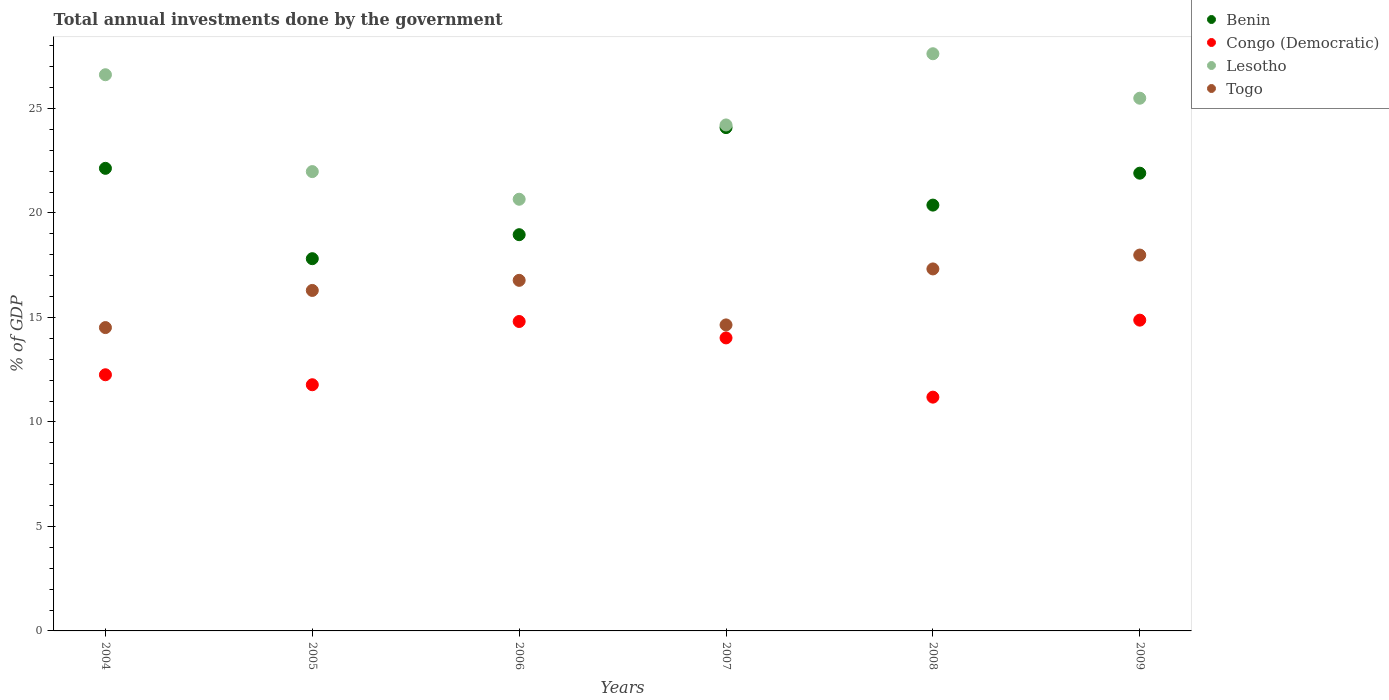How many different coloured dotlines are there?
Your answer should be compact. 4. What is the total annual investments done by the government in Togo in 2006?
Ensure brevity in your answer.  16.77. Across all years, what is the maximum total annual investments done by the government in Congo (Democratic)?
Offer a terse response. 14.87. Across all years, what is the minimum total annual investments done by the government in Togo?
Provide a succinct answer. 14.51. In which year was the total annual investments done by the government in Togo maximum?
Keep it short and to the point. 2009. In which year was the total annual investments done by the government in Togo minimum?
Your answer should be compact. 2004. What is the total total annual investments done by the government in Benin in the graph?
Your response must be concise. 125.27. What is the difference between the total annual investments done by the government in Lesotho in 2008 and that in 2009?
Offer a very short reply. 2.13. What is the difference between the total annual investments done by the government in Lesotho in 2006 and the total annual investments done by the government in Togo in 2004?
Ensure brevity in your answer.  6.14. What is the average total annual investments done by the government in Benin per year?
Offer a very short reply. 20.88. In the year 2006, what is the difference between the total annual investments done by the government in Congo (Democratic) and total annual investments done by the government in Togo?
Your answer should be very brief. -1.97. In how many years, is the total annual investments done by the government in Benin greater than 23 %?
Make the answer very short. 1. What is the ratio of the total annual investments done by the government in Benin in 2004 to that in 2007?
Give a very brief answer. 0.92. What is the difference between the highest and the second highest total annual investments done by the government in Benin?
Provide a short and direct response. 1.95. What is the difference between the highest and the lowest total annual investments done by the government in Congo (Democratic)?
Your answer should be very brief. 3.68. Is it the case that in every year, the sum of the total annual investments done by the government in Lesotho and total annual investments done by the government in Congo (Democratic)  is greater than the total annual investments done by the government in Benin?
Offer a very short reply. Yes. Does the total annual investments done by the government in Congo (Democratic) monotonically increase over the years?
Your response must be concise. No. Is the total annual investments done by the government in Benin strictly greater than the total annual investments done by the government in Togo over the years?
Your response must be concise. Yes. How many dotlines are there?
Your answer should be very brief. 4. What is the difference between two consecutive major ticks on the Y-axis?
Your answer should be very brief. 5. Where does the legend appear in the graph?
Provide a short and direct response. Top right. How are the legend labels stacked?
Ensure brevity in your answer.  Vertical. What is the title of the graph?
Provide a short and direct response. Total annual investments done by the government. What is the label or title of the X-axis?
Your answer should be compact. Years. What is the label or title of the Y-axis?
Your response must be concise. % of GDP. What is the % of GDP in Benin in 2004?
Give a very brief answer. 22.13. What is the % of GDP in Congo (Democratic) in 2004?
Your response must be concise. 12.26. What is the % of GDP of Lesotho in 2004?
Offer a terse response. 26.61. What is the % of GDP of Togo in 2004?
Offer a very short reply. 14.51. What is the % of GDP of Benin in 2005?
Offer a terse response. 17.81. What is the % of GDP in Congo (Democratic) in 2005?
Provide a short and direct response. 11.78. What is the % of GDP of Lesotho in 2005?
Make the answer very short. 21.98. What is the % of GDP in Togo in 2005?
Provide a succinct answer. 16.29. What is the % of GDP of Benin in 2006?
Make the answer very short. 18.96. What is the % of GDP in Congo (Democratic) in 2006?
Provide a succinct answer. 14.81. What is the % of GDP in Lesotho in 2006?
Make the answer very short. 20.66. What is the % of GDP in Togo in 2006?
Offer a terse response. 16.77. What is the % of GDP of Benin in 2007?
Make the answer very short. 24.08. What is the % of GDP of Congo (Democratic) in 2007?
Your response must be concise. 14.02. What is the % of GDP in Lesotho in 2007?
Your answer should be compact. 24.21. What is the % of GDP in Togo in 2007?
Your answer should be very brief. 14.64. What is the % of GDP of Benin in 2008?
Make the answer very short. 20.38. What is the % of GDP of Congo (Democratic) in 2008?
Offer a very short reply. 11.19. What is the % of GDP of Lesotho in 2008?
Your response must be concise. 27.62. What is the % of GDP in Togo in 2008?
Your answer should be very brief. 17.32. What is the % of GDP in Benin in 2009?
Your answer should be compact. 21.9. What is the % of GDP of Congo (Democratic) in 2009?
Offer a very short reply. 14.87. What is the % of GDP of Lesotho in 2009?
Offer a very short reply. 25.49. What is the % of GDP in Togo in 2009?
Your answer should be compact. 17.98. Across all years, what is the maximum % of GDP of Benin?
Your answer should be compact. 24.08. Across all years, what is the maximum % of GDP of Congo (Democratic)?
Your answer should be compact. 14.87. Across all years, what is the maximum % of GDP of Lesotho?
Make the answer very short. 27.62. Across all years, what is the maximum % of GDP of Togo?
Provide a succinct answer. 17.98. Across all years, what is the minimum % of GDP in Benin?
Provide a short and direct response. 17.81. Across all years, what is the minimum % of GDP in Congo (Democratic)?
Provide a succinct answer. 11.19. Across all years, what is the minimum % of GDP of Lesotho?
Offer a very short reply. 20.66. Across all years, what is the minimum % of GDP in Togo?
Ensure brevity in your answer.  14.51. What is the total % of GDP of Benin in the graph?
Make the answer very short. 125.27. What is the total % of GDP of Congo (Democratic) in the graph?
Your answer should be very brief. 78.92. What is the total % of GDP of Lesotho in the graph?
Ensure brevity in your answer.  146.56. What is the total % of GDP in Togo in the graph?
Keep it short and to the point. 97.53. What is the difference between the % of GDP of Benin in 2004 and that in 2005?
Provide a short and direct response. 4.32. What is the difference between the % of GDP in Congo (Democratic) in 2004 and that in 2005?
Offer a terse response. 0.48. What is the difference between the % of GDP of Lesotho in 2004 and that in 2005?
Keep it short and to the point. 4.63. What is the difference between the % of GDP in Togo in 2004 and that in 2005?
Give a very brief answer. -1.78. What is the difference between the % of GDP in Benin in 2004 and that in 2006?
Provide a short and direct response. 3.17. What is the difference between the % of GDP in Congo (Democratic) in 2004 and that in 2006?
Offer a very short reply. -2.55. What is the difference between the % of GDP in Lesotho in 2004 and that in 2006?
Your response must be concise. 5.96. What is the difference between the % of GDP in Togo in 2004 and that in 2006?
Provide a short and direct response. -2.26. What is the difference between the % of GDP in Benin in 2004 and that in 2007?
Ensure brevity in your answer.  -1.95. What is the difference between the % of GDP in Congo (Democratic) in 2004 and that in 2007?
Offer a very short reply. -1.76. What is the difference between the % of GDP in Lesotho in 2004 and that in 2007?
Your answer should be very brief. 2.4. What is the difference between the % of GDP in Togo in 2004 and that in 2007?
Offer a terse response. -0.13. What is the difference between the % of GDP in Benin in 2004 and that in 2008?
Your answer should be very brief. 1.76. What is the difference between the % of GDP in Congo (Democratic) in 2004 and that in 2008?
Make the answer very short. 1.07. What is the difference between the % of GDP in Lesotho in 2004 and that in 2008?
Provide a succinct answer. -1. What is the difference between the % of GDP of Togo in 2004 and that in 2008?
Ensure brevity in your answer.  -2.81. What is the difference between the % of GDP of Benin in 2004 and that in 2009?
Keep it short and to the point. 0.23. What is the difference between the % of GDP of Congo (Democratic) in 2004 and that in 2009?
Offer a very short reply. -2.61. What is the difference between the % of GDP in Lesotho in 2004 and that in 2009?
Keep it short and to the point. 1.12. What is the difference between the % of GDP in Togo in 2004 and that in 2009?
Provide a succinct answer. -3.47. What is the difference between the % of GDP in Benin in 2005 and that in 2006?
Provide a succinct answer. -1.15. What is the difference between the % of GDP of Congo (Democratic) in 2005 and that in 2006?
Provide a succinct answer. -3.03. What is the difference between the % of GDP in Lesotho in 2005 and that in 2006?
Your answer should be very brief. 1.32. What is the difference between the % of GDP in Togo in 2005 and that in 2006?
Provide a succinct answer. -0.48. What is the difference between the % of GDP of Benin in 2005 and that in 2007?
Keep it short and to the point. -6.27. What is the difference between the % of GDP in Congo (Democratic) in 2005 and that in 2007?
Ensure brevity in your answer.  -2.24. What is the difference between the % of GDP of Lesotho in 2005 and that in 2007?
Provide a succinct answer. -2.23. What is the difference between the % of GDP in Togo in 2005 and that in 2007?
Give a very brief answer. 1.65. What is the difference between the % of GDP of Benin in 2005 and that in 2008?
Your answer should be compact. -2.56. What is the difference between the % of GDP in Congo (Democratic) in 2005 and that in 2008?
Give a very brief answer. 0.59. What is the difference between the % of GDP in Lesotho in 2005 and that in 2008?
Give a very brief answer. -5.64. What is the difference between the % of GDP in Togo in 2005 and that in 2008?
Ensure brevity in your answer.  -1.03. What is the difference between the % of GDP in Benin in 2005 and that in 2009?
Give a very brief answer. -4.09. What is the difference between the % of GDP of Congo (Democratic) in 2005 and that in 2009?
Your answer should be compact. -3.09. What is the difference between the % of GDP of Lesotho in 2005 and that in 2009?
Offer a very short reply. -3.51. What is the difference between the % of GDP of Togo in 2005 and that in 2009?
Give a very brief answer. -1.69. What is the difference between the % of GDP in Benin in 2006 and that in 2007?
Provide a short and direct response. -5.12. What is the difference between the % of GDP in Congo (Democratic) in 2006 and that in 2007?
Your answer should be compact. 0.79. What is the difference between the % of GDP in Lesotho in 2006 and that in 2007?
Keep it short and to the point. -3.56. What is the difference between the % of GDP of Togo in 2006 and that in 2007?
Offer a terse response. 2.13. What is the difference between the % of GDP in Benin in 2006 and that in 2008?
Make the answer very short. -1.42. What is the difference between the % of GDP in Congo (Democratic) in 2006 and that in 2008?
Provide a short and direct response. 3.62. What is the difference between the % of GDP in Lesotho in 2006 and that in 2008?
Your answer should be compact. -6.96. What is the difference between the % of GDP in Togo in 2006 and that in 2008?
Provide a short and direct response. -0.55. What is the difference between the % of GDP in Benin in 2006 and that in 2009?
Ensure brevity in your answer.  -2.94. What is the difference between the % of GDP of Congo (Democratic) in 2006 and that in 2009?
Your answer should be very brief. -0.06. What is the difference between the % of GDP of Lesotho in 2006 and that in 2009?
Your response must be concise. -4.83. What is the difference between the % of GDP in Togo in 2006 and that in 2009?
Provide a succinct answer. -1.21. What is the difference between the % of GDP in Benin in 2007 and that in 2008?
Make the answer very short. 3.71. What is the difference between the % of GDP in Congo (Democratic) in 2007 and that in 2008?
Your answer should be very brief. 2.83. What is the difference between the % of GDP in Lesotho in 2007 and that in 2008?
Your response must be concise. -3.41. What is the difference between the % of GDP of Togo in 2007 and that in 2008?
Ensure brevity in your answer.  -2.68. What is the difference between the % of GDP in Benin in 2007 and that in 2009?
Keep it short and to the point. 2.18. What is the difference between the % of GDP in Congo (Democratic) in 2007 and that in 2009?
Your answer should be very brief. -0.85. What is the difference between the % of GDP in Lesotho in 2007 and that in 2009?
Your response must be concise. -1.28. What is the difference between the % of GDP in Togo in 2007 and that in 2009?
Your answer should be compact. -3.34. What is the difference between the % of GDP of Benin in 2008 and that in 2009?
Offer a terse response. -1.53. What is the difference between the % of GDP in Congo (Democratic) in 2008 and that in 2009?
Your response must be concise. -3.68. What is the difference between the % of GDP in Lesotho in 2008 and that in 2009?
Ensure brevity in your answer.  2.13. What is the difference between the % of GDP in Togo in 2008 and that in 2009?
Provide a short and direct response. -0.66. What is the difference between the % of GDP in Benin in 2004 and the % of GDP in Congo (Democratic) in 2005?
Your answer should be very brief. 10.35. What is the difference between the % of GDP of Benin in 2004 and the % of GDP of Lesotho in 2005?
Give a very brief answer. 0.16. What is the difference between the % of GDP in Benin in 2004 and the % of GDP in Togo in 2005?
Make the answer very short. 5.84. What is the difference between the % of GDP of Congo (Democratic) in 2004 and the % of GDP of Lesotho in 2005?
Your answer should be compact. -9.72. What is the difference between the % of GDP in Congo (Democratic) in 2004 and the % of GDP in Togo in 2005?
Provide a short and direct response. -4.04. What is the difference between the % of GDP of Lesotho in 2004 and the % of GDP of Togo in 2005?
Your response must be concise. 10.32. What is the difference between the % of GDP in Benin in 2004 and the % of GDP in Congo (Democratic) in 2006?
Ensure brevity in your answer.  7.33. What is the difference between the % of GDP in Benin in 2004 and the % of GDP in Lesotho in 2006?
Ensure brevity in your answer.  1.48. What is the difference between the % of GDP of Benin in 2004 and the % of GDP of Togo in 2006?
Offer a terse response. 5.36. What is the difference between the % of GDP in Congo (Democratic) in 2004 and the % of GDP in Lesotho in 2006?
Offer a terse response. -8.4. What is the difference between the % of GDP of Congo (Democratic) in 2004 and the % of GDP of Togo in 2006?
Your response must be concise. -4.52. What is the difference between the % of GDP in Lesotho in 2004 and the % of GDP in Togo in 2006?
Your answer should be very brief. 9.84. What is the difference between the % of GDP of Benin in 2004 and the % of GDP of Congo (Democratic) in 2007?
Offer a terse response. 8.11. What is the difference between the % of GDP of Benin in 2004 and the % of GDP of Lesotho in 2007?
Offer a terse response. -2.08. What is the difference between the % of GDP of Benin in 2004 and the % of GDP of Togo in 2007?
Offer a terse response. 7.49. What is the difference between the % of GDP in Congo (Democratic) in 2004 and the % of GDP in Lesotho in 2007?
Give a very brief answer. -11.95. What is the difference between the % of GDP in Congo (Democratic) in 2004 and the % of GDP in Togo in 2007?
Provide a succinct answer. -2.39. What is the difference between the % of GDP in Lesotho in 2004 and the % of GDP in Togo in 2007?
Keep it short and to the point. 11.97. What is the difference between the % of GDP of Benin in 2004 and the % of GDP of Congo (Democratic) in 2008?
Your response must be concise. 10.95. What is the difference between the % of GDP of Benin in 2004 and the % of GDP of Lesotho in 2008?
Offer a very short reply. -5.48. What is the difference between the % of GDP in Benin in 2004 and the % of GDP in Togo in 2008?
Provide a short and direct response. 4.81. What is the difference between the % of GDP in Congo (Democratic) in 2004 and the % of GDP in Lesotho in 2008?
Your answer should be compact. -15.36. What is the difference between the % of GDP in Congo (Democratic) in 2004 and the % of GDP in Togo in 2008?
Make the answer very short. -5.06. What is the difference between the % of GDP in Lesotho in 2004 and the % of GDP in Togo in 2008?
Ensure brevity in your answer.  9.29. What is the difference between the % of GDP of Benin in 2004 and the % of GDP of Congo (Democratic) in 2009?
Ensure brevity in your answer.  7.26. What is the difference between the % of GDP of Benin in 2004 and the % of GDP of Lesotho in 2009?
Make the answer very short. -3.36. What is the difference between the % of GDP in Benin in 2004 and the % of GDP in Togo in 2009?
Provide a short and direct response. 4.15. What is the difference between the % of GDP of Congo (Democratic) in 2004 and the % of GDP of Lesotho in 2009?
Provide a short and direct response. -13.23. What is the difference between the % of GDP of Congo (Democratic) in 2004 and the % of GDP of Togo in 2009?
Give a very brief answer. -5.73. What is the difference between the % of GDP in Lesotho in 2004 and the % of GDP in Togo in 2009?
Give a very brief answer. 8.63. What is the difference between the % of GDP in Benin in 2005 and the % of GDP in Congo (Democratic) in 2006?
Make the answer very short. 3.01. What is the difference between the % of GDP of Benin in 2005 and the % of GDP of Lesotho in 2006?
Keep it short and to the point. -2.84. What is the difference between the % of GDP of Benin in 2005 and the % of GDP of Togo in 2006?
Provide a short and direct response. 1.04. What is the difference between the % of GDP in Congo (Democratic) in 2005 and the % of GDP in Lesotho in 2006?
Ensure brevity in your answer.  -8.88. What is the difference between the % of GDP in Congo (Democratic) in 2005 and the % of GDP in Togo in 2006?
Ensure brevity in your answer.  -5. What is the difference between the % of GDP in Lesotho in 2005 and the % of GDP in Togo in 2006?
Provide a short and direct response. 5.2. What is the difference between the % of GDP in Benin in 2005 and the % of GDP in Congo (Democratic) in 2007?
Ensure brevity in your answer.  3.79. What is the difference between the % of GDP in Benin in 2005 and the % of GDP in Lesotho in 2007?
Your answer should be compact. -6.4. What is the difference between the % of GDP of Benin in 2005 and the % of GDP of Togo in 2007?
Ensure brevity in your answer.  3.17. What is the difference between the % of GDP of Congo (Democratic) in 2005 and the % of GDP of Lesotho in 2007?
Your answer should be compact. -12.43. What is the difference between the % of GDP of Congo (Democratic) in 2005 and the % of GDP of Togo in 2007?
Offer a very short reply. -2.86. What is the difference between the % of GDP in Lesotho in 2005 and the % of GDP in Togo in 2007?
Provide a succinct answer. 7.34. What is the difference between the % of GDP in Benin in 2005 and the % of GDP in Congo (Democratic) in 2008?
Your answer should be compact. 6.62. What is the difference between the % of GDP in Benin in 2005 and the % of GDP in Lesotho in 2008?
Provide a short and direct response. -9.81. What is the difference between the % of GDP in Benin in 2005 and the % of GDP in Togo in 2008?
Your answer should be very brief. 0.49. What is the difference between the % of GDP of Congo (Democratic) in 2005 and the % of GDP of Lesotho in 2008?
Offer a terse response. -15.84. What is the difference between the % of GDP of Congo (Democratic) in 2005 and the % of GDP of Togo in 2008?
Keep it short and to the point. -5.54. What is the difference between the % of GDP of Lesotho in 2005 and the % of GDP of Togo in 2008?
Your answer should be very brief. 4.66. What is the difference between the % of GDP in Benin in 2005 and the % of GDP in Congo (Democratic) in 2009?
Your answer should be very brief. 2.94. What is the difference between the % of GDP of Benin in 2005 and the % of GDP of Lesotho in 2009?
Give a very brief answer. -7.68. What is the difference between the % of GDP of Benin in 2005 and the % of GDP of Togo in 2009?
Your answer should be compact. -0.17. What is the difference between the % of GDP of Congo (Democratic) in 2005 and the % of GDP of Lesotho in 2009?
Make the answer very short. -13.71. What is the difference between the % of GDP of Congo (Democratic) in 2005 and the % of GDP of Togo in 2009?
Your answer should be very brief. -6.21. What is the difference between the % of GDP in Lesotho in 2005 and the % of GDP in Togo in 2009?
Your response must be concise. 3.99. What is the difference between the % of GDP in Benin in 2006 and the % of GDP in Congo (Democratic) in 2007?
Your answer should be compact. 4.94. What is the difference between the % of GDP of Benin in 2006 and the % of GDP of Lesotho in 2007?
Provide a short and direct response. -5.25. What is the difference between the % of GDP of Benin in 2006 and the % of GDP of Togo in 2007?
Offer a very short reply. 4.32. What is the difference between the % of GDP in Congo (Democratic) in 2006 and the % of GDP in Lesotho in 2007?
Your answer should be very brief. -9.4. What is the difference between the % of GDP in Congo (Democratic) in 2006 and the % of GDP in Togo in 2007?
Offer a very short reply. 0.16. What is the difference between the % of GDP of Lesotho in 2006 and the % of GDP of Togo in 2007?
Your answer should be very brief. 6.01. What is the difference between the % of GDP in Benin in 2006 and the % of GDP in Congo (Democratic) in 2008?
Keep it short and to the point. 7.77. What is the difference between the % of GDP in Benin in 2006 and the % of GDP in Lesotho in 2008?
Ensure brevity in your answer.  -8.66. What is the difference between the % of GDP in Benin in 2006 and the % of GDP in Togo in 2008?
Keep it short and to the point. 1.64. What is the difference between the % of GDP of Congo (Democratic) in 2006 and the % of GDP of Lesotho in 2008?
Your answer should be compact. -12.81. What is the difference between the % of GDP in Congo (Democratic) in 2006 and the % of GDP in Togo in 2008?
Provide a short and direct response. -2.52. What is the difference between the % of GDP of Lesotho in 2006 and the % of GDP of Togo in 2008?
Make the answer very short. 3.33. What is the difference between the % of GDP in Benin in 2006 and the % of GDP in Congo (Democratic) in 2009?
Offer a terse response. 4.09. What is the difference between the % of GDP in Benin in 2006 and the % of GDP in Lesotho in 2009?
Your response must be concise. -6.53. What is the difference between the % of GDP in Benin in 2006 and the % of GDP in Togo in 2009?
Your response must be concise. 0.97. What is the difference between the % of GDP of Congo (Democratic) in 2006 and the % of GDP of Lesotho in 2009?
Make the answer very short. -10.68. What is the difference between the % of GDP in Congo (Democratic) in 2006 and the % of GDP in Togo in 2009?
Provide a succinct answer. -3.18. What is the difference between the % of GDP in Lesotho in 2006 and the % of GDP in Togo in 2009?
Your response must be concise. 2.67. What is the difference between the % of GDP in Benin in 2007 and the % of GDP in Congo (Democratic) in 2008?
Your answer should be very brief. 12.9. What is the difference between the % of GDP of Benin in 2007 and the % of GDP of Lesotho in 2008?
Your answer should be very brief. -3.54. What is the difference between the % of GDP of Benin in 2007 and the % of GDP of Togo in 2008?
Keep it short and to the point. 6.76. What is the difference between the % of GDP of Congo (Democratic) in 2007 and the % of GDP of Lesotho in 2008?
Keep it short and to the point. -13.6. What is the difference between the % of GDP of Congo (Democratic) in 2007 and the % of GDP of Togo in 2008?
Make the answer very short. -3.3. What is the difference between the % of GDP of Lesotho in 2007 and the % of GDP of Togo in 2008?
Your answer should be very brief. 6.89. What is the difference between the % of GDP in Benin in 2007 and the % of GDP in Congo (Democratic) in 2009?
Provide a succinct answer. 9.21. What is the difference between the % of GDP of Benin in 2007 and the % of GDP of Lesotho in 2009?
Give a very brief answer. -1.41. What is the difference between the % of GDP of Benin in 2007 and the % of GDP of Togo in 2009?
Keep it short and to the point. 6.1. What is the difference between the % of GDP in Congo (Democratic) in 2007 and the % of GDP in Lesotho in 2009?
Your answer should be very brief. -11.47. What is the difference between the % of GDP of Congo (Democratic) in 2007 and the % of GDP of Togo in 2009?
Give a very brief answer. -3.96. What is the difference between the % of GDP in Lesotho in 2007 and the % of GDP in Togo in 2009?
Offer a terse response. 6.23. What is the difference between the % of GDP in Benin in 2008 and the % of GDP in Congo (Democratic) in 2009?
Your answer should be compact. 5.5. What is the difference between the % of GDP of Benin in 2008 and the % of GDP of Lesotho in 2009?
Provide a short and direct response. -5.11. What is the difference between the % of GDP in Benin in 2008 and the % of GDP in Togo in 2009?
Offer a very short reply. 2.39. What is the difference between the % of GDP in Congo (Democratic) in 2008 and the % of GDP in Lesotho in 2009?
Offer a very short reply. -14.3. What is the difference between the % of GDP of Congo (Democratic) in 2008 and the % of GDP of Togo in 2009?
Ensure brevity in your answer.  -6.8. What is the difference between the % of GDP in Lesotho in 2008 and the % of GDP in Togo in 2009?
Your response must be concise. 9.63. What is the average % of GDP in Benin per year?
Your response must be concise. 20.88. What is the average % of GDP in Congo (Democratic) per year?
Ensure brevity in your answer.  13.15. What is the average % of GDP in Lesotho per year?
Keep it short and to the point. 24.43. What is the average % of GDP in Togo per year?
Make the answer very short. 16.26. In the year 2004, what is the difference between the % of GDP of Benin and % of GDP of Congo (Democratic)?
Ensure brevity in your answer.  9.88. In the year 2004, what is the difference between the % of GDP of Benin and % of GDP of Lesotho?
Give a very brief answer. -4.48. In the year 2004, what is the difference between the % of GDP of Benin and % of GDP of Togo?
Ensure brevity in your answer.  7.62. In the year 2004, what is the difference between the % of GDP in Congo (Democratic) and % of GDP in Lesotho?
Provide a succinct answer. -14.36. In the year 2004, what is the difference between the % of GDP of Congo (Democratic) and % of GDP of Togo?
Keep it short and to the point. -2.26. In the year 2004, what is the difference between the % of GDP of Lesotho and % of GDP of Togo?
Your answer should be compact. 12.1. In the year 2005, what is the difference between the % of GDP of Benin and % of GDP of Congo (Democratic)?
Ensure brevity in your answer.  6.03. In the year 2005, what is the difference between the % of GDP in Benin and % of GDP in Lesotho?
Offer a very short reply. -4.17. In the year 2005, what is the difference between the % of GDP in Benin and % of GDP in Togo?
Offer a very short reply. 1.52. In the year 2005, what is the difference between the % of GDP of Congo (Democratic) and % of GDP of Lesotho?
Give a very brief answer. -10.2. In the year 2005, what is the difference between the % of GDP in Congo (Democratic) and % of GDP in Togo?
Make the answer very short. -4.51. In the year 2005, what is the difference between the % of GDP in Lesotho and % of GDP in Togo?
Keep it short and to the point. 5.69. In the year 2006, what is the difference between the % of GDP in Benin and % of GDP in Congo (Democratic)?
Ensure brevity in your answer.  4.15. In the year 2006, what is the difference between the % of GDP in Benin and % of GDP in Lesotho?
Ensure brevity in your answer.  -1.7. In the year 2006, what is the difference between the % of GDP of Benin and % of GDP of Togo?
Provide a succinct answer. 2.18. In the year 2006, what is the difference between the % of GDP in Congo (Democratic) and % of GDP in Lesotho?
Your response must be concise. -5.85. In the year 2006, what is the difference between the % of GDP in Congo (Democratic) and % of GDP in Togo?
Provide a succinct answer. -1.97. In the year 2006, what is the difference between the % of GDP of Lesotho and % of GDP of Togo?
Ensure brevity in your answer.  3.88. In the year 2007, what is the difference between the % of GDP in Benin and % of GDP in Congo (Democratic)?
Your response must be concise. 10.06. In the year 2007, what is the difference between the % of GDP in Benin and % of GDP in Lesotho?
Your response must be concise. -0.13. In the year 2007, what is the difference between the % of GDP in Benin and % of GDP in Togo?
Your answer should be compact. 9.44. In the year 2007, what is the difference between the % of GDP in Congo (Democratic) and % of GDP in Lesotho?
Offer a very short reply. -10.19. In the year 2007, what is the difference between the % of GDP of Congo (Democratic) and % of GDP of Togo?
Your answer should be compact. -0.62. In the year 2007, what is the difference between the % of GDP of Lesotho and % of GDP of Togo?
Ensure brevity in your answer.  9.57. In the year 2008, what is the difference between the % of GDP in Benin and % of GDP in Congo (Democratic)?
Your answer should be compact. 9.19. In the year 2008, what is the difference between the % of GDP of Benin and % of GDP of Lesotho?
Make the answer very short. -7.24. In the year 2008, what is the difference between the % of GDP in Benin and % of GDP in Togo?
Keep it short and to the point. 3.05. In the year 2008, what is the difference between the % of GDP of Congo (Democratic) and % of GDP of Lesotho?
Offer a very short reply. -16.43. In the year 2008, what is the difference between the % of GDP in Congo (Democratic) and % of GDP in Togo?
Offer a terse response. -6.14. In the year 2008, what is the difference between the % of GDP of Lesotho and % of GDP of Togo?
Offer a terse response. 10.3. In the year 2009, what is the difference between the % of GDP of Benin and % of GDP of Congo (Democratic)?
Offer a very short reply. 7.03. In the year 2009, what is the difference between the % of GDP of Benin and % of GDP of Lesotho?
Provide a short and direct response. -3.59. In the year 2009, what is the difference between the % of GDP in Benin and % of GDP in Togo?
Your response must be concise. 3.92. In the year 2009, what is the difference between the % of GDP of Congo (Democratic) and % of GDP of Lesotho?
Your answer should be very brief. -10.62. In the year 2009, what is the difference between the % of GDP of Congo (Democratic) and % of GDP of Togo?
Give a very brief answer. -3.11. In the year 2009, what is the difference between the % of GDP in Lesotho and % of GDP in Togo?
Provide a succinct answer. 7.5. What is the ratio of the % of GDP in Benin in 2004 to that in 2005?
Provide a short and direct response. 1.24. What is the ratio of the % of GDP in Congo (Democratic) in 2004 to that in 2005?
Offer a terse response. 1.04. What is the ratio of the % of GDP in Lesotho in 2004 to that in 2005?
Ensure brevity in your answer.  1.21. What is the ratio of the % of GDP of Togo in 2004 to that in 2005?
Ensure brevity in your answer.  0.89. What is the ratio of the % of GDP in Benin in 2004 to that in 2006?
Your answer should be compact. 1.17. What is the ratio of the % of GDP of Congo (Democratic) in 2004 to that in 2006?
Offer a very short reply. 0.83. What is the ratio of the % of GDP in Lesotho in 2004 to that in 2006?
Your answer should be very brief. 1.29. What is the ratio of the % of GDP in Togo in 2004 to that in 2006?
Your answer should be compact. 0.87. What is the ratio of the % of GDP in Benin in 2004 to that in 2007?
Provide a short and direct response. 0.92. What is the ratio of the % of GDP in Congo (Democratic) in 2004 to that in 2007?
Offer a terse response. 0.87. What is the ratio of the % of GDP of Lesotho in 2004 to that in 2007?
Keep it short and to the point. 1.1. What is the ratio of the % of GDP in Togo in 2004 to that in 2007?
Make the answer very short. 0.99. What is the ratio of the % of GDP in Benin in 2004 to that in 2008?
Provide a succinct answer. 1.09. What is the ratio of the % of GDP of Congo (Democratic) in 2004 to that in 2008?
Your answer should be compact. 1.1. What is the ratio of the % of GDP in Lesotho in 2004 to that in 2008?
Provide a short and direct response. 0.96. What is the ratio of the % of GDP in Togo in 2004 to that in 2008?
Provide a short and direct response. 0.84. What is the ratio of the % of GDP in Benin in 2004 to that in 2009?
Your answer should be very brief. 1.01. What is the ratio of the % of GDP of Congo (Democratic) in 2004 to that in 2009?
Ensure brevity in your answer.  0.82. What is the ratio of the % of GDP in Lesotho in 2004 to that in 2009?
Make the answer very short. 1.04. What is the ratio of the % of GDP in Togo in 2004 to that in 2009?
Give a very brief answer. 0.81. What is the ratio of the % of GDP of Benin in 2005 to that in 2006?
Your answer should be compact. 0.94. What is the ratio of the % of GDP in Congo (Democratic) in 2005 to that in 2006?
Keep it short and to the point. 0.8. What is the ratio of the % of GDP of Lesotho in 2005 to that in 2006?
Keep it short and to the point. 1.06. What is the ratio of the % of GDP of Togo in 2005 to that in 2006?
Ensure brevity in your answer.  0.97. What is the ratio of the % of GDP in Benin in 2005 to that in 2007?
Offer a very short reply. 0.74. What is the ratio of the % of GDP of Congo (Democratic) in 2005 to that in 2007?
Keep it short and to the point. 0.84. What is the ratio of the % of GDP of Lesotho in 2005 to that in 2007?
Offer a terse response. 0.91. What is the ratio of the % of GDP in Togo in 2005 to that in 2007?
Your answer should be very brief. 1.11. What is the ratio of the % of GDP in Benin in 2005 to that in 2008?
Offer a very short reply. 0.87. What is the ratio of the % of GDP in Congo (Democratic) in 2005 to that in 2008?
Keep it short and to the point. 1.05. What is the ratio of the % of GDP of Lesotho in 2005 to that in 2008?
Make the answer very short. 0.8. What is the ratio of the % of GDP of Togo in 2005 to that in 2008?
Your answer should be very brief. 0.94. What is the ratio of the % of GDP of Benin in 2005 to that in 2009?
Keep it short and to the point. 0.81. What is the ratio of the % of GDP in Congo (Democratic) in 2005 to that in 2009?
Your answer should be compact. 0.79. What is the ratio of the % of GDP in Lesotho in 2005 to that in 2009?
Your answer should be compact. 0.86. What is the ratio of the % of GDP in Togo in 2005 to that in 2009?
Your answer should be very brief. 0.91. What is the ratio of the % of GDP in Benin in 2006 to that in 2007?
Offer a very short reply. 0.79. What is the ratio of the % of GDP in Congo (Democratic) in 2006 to that in 2007?
Your answer should be very brief. 1.06. What is the ratio of the % of GDP of Lesotho in 2006 to that in 2007?
Keep it short and to the point. 0.85. What is the ratio of the % of GDP of Togo in 2006 to that in 2007?
Offer a very short reply. 1.15. What is the ratio of the % of GDP of Benin in 2006 to that in 2008?
Make the answer very short. 0.93. What is the ratio of the % of GDP in Congo (Democratic) in 2006 to that in 2008?
Give a very brief answer. 1.32. What is the ratio of the % of GDP of Lesotho in 2006 to that in 2008?
Make the answer very short. 0.75. What is the ratio of the % of GDP in Togo in 2006 to that in 2008?
Your answer should be compact. 0.97. What is the ratio of the % of GDP of Benin in 2006 to that in 2009?
Keep it short and to the point. 0.87. What is the ratio of the % of GDP in Lesotho in 2006 to that in 2009?
Keep it short and to the point. 0.81. What is the ratio of the % of GDP of Togo in 2006 to that in 2009?
Ensure brevity in your answer.  0.93. What is the ratio of the % of GDP of Benin in 2007 to that in 2008?
Provide a short and direct response. 1.18. What is the ratio of the % of GDP of Congo (Democratic) in 2007 to that in 2008?
Your answer should be very brief. 1.25. What is the ratio of the % of GDP in Lesotho in 2007 to that in 2008?
Ensure brevity in your answer.  0.88. What is the ratio of the % of GDP in Togo in 2007 to that in 2008?
Give a very brief answer. 0.85. What is the ratio of the % of GDP of Benin in 2007 to that in 2009?
Your answer should be very brief. 1.1. What is the ratio of the % of GDP of Congo (Democratic) in 2007 to that in 2009?
Provide a succinct answer. 0.94. What is the ratio of the % of GDP in Lesotho in 2007 to that in 2009?
Your answer should be very brief. 0.95. What is the ratio of the % of GDP in Togo in 2007 to that in 2009?
Make the answer very short. 0.81. What is the ratio of the % of GDP of Benin in 2008 to that in 2009?
Provide a succinct answer. 0.93. What is the ratio of the % of GDP of Congo (Democratic) in 2008 to that in 2009?
Offer a terse response. 0.75. What is the ratio of the % of GDP in Lesotho in 2008 to that in 2009?
Ensure brevity in your answer.  1.08. What is the ratio of the % of GDP in Togo in 2008 to that in 2009?
Provide a succinct answer. 0.96. What is the difference between the highest and the second highest % of GDP of Benin?
Provide a succinct answer. 1.95. What is the difference between the highest and the second highest % of GDP in Congo (Democratic)?
Give a very brief answer. 0.06. What is the difference between the highest and the second highest % of GDP in Togo?
Provide a succinct answer. 0.66. What is the difference between the highest and the lowest % of GDP of Benin?
Offer a very short reply. 6.27. What is the difference between the highest and the lowest % of GDP in Congo (Democratic)?
Offer a terse response. 3.68. What is the difference between the highest and the lowest % of GDP in Lesotho?
Ensure brevity in your answer.  6.96. What is the difference between the highest and the lowest % of GDP in Togo?
Provide a short and direct response. 3.47. 